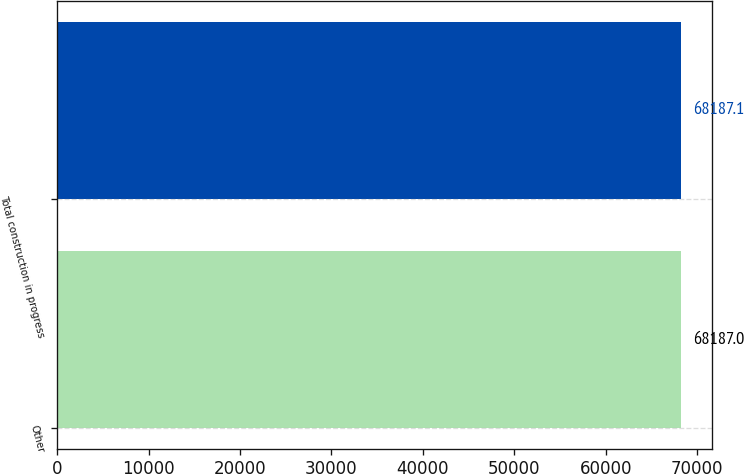Convert chart. <chart><loc_0><loc_0><loc_500><loc_500><bar_chart><fcel>Other<fcel>Total construction in progress<nl><fcel>68187<fcel>68187.1<nl></chart> 